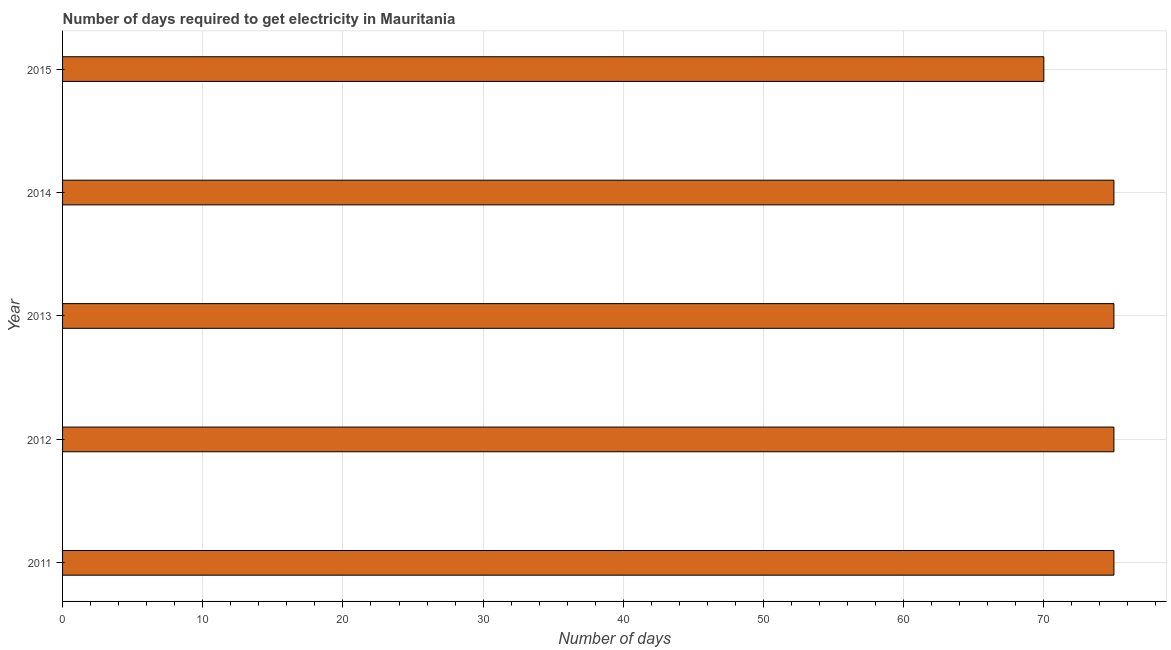What is the title of the graph?
Provide a short and direct response. Number of days required to get electricity in Mauritania. What is the label or title of the X-axis?
Your answer should be very brief. Number of days. What is the label or title of the Y-axis?
Make the answer very short. Year. In which year was the time to get electricity maximum?
Offer a terse response. 2011. In which year was the time to get electricity minimum?
Keep it short and to the point. 2015. What is the sum of the time to get electricity?
Give a very brief answer. 370. What is the difference between the time to get electricity in 2011 and 2013?
Your answer should be compact. 0. What is the median time to get electricity?
Keep it short and to the point. 75. In how many years, is the time to get electricity greater than 12 ?
Offer a terse response. 5. What is the ratio of the time to get electricity in 2012 to that in 2015?
Ensure brevity in your answer.  1.07. Is the difference between the time to get electricity in 2011 and 2015 greater than the difference between any two years?
Ensure brevity in your answer.  Yes. What is the difference between the highest and the second highest time to get electricity?
Provide a succinct answer. 0. In how many years, is the time to get electricity greater than the average time to get electricity taken over all years?
Keep it short and to the point. 4. How many years are there in the graph?
Give a very brief answer. 5. What is the Number of days in 2011?
Make the answer very short. 75. What is the Number of days in 2013?
Offer a terse response. 75. What is the difference between the Number of days in 2011 and 2012?
Keep it short and to the point. 0. What is the difference between the Number of days in 2011 and 2013?
Offer a very short reply. 0. What is the difference between the Number of days in 2011 and 2014?
Provide a short and direct response. 0. What is the difference between the Number of days in 2011 and 2015?
Make the answer very short. 5. What is the difference between the Number of days in 2012 and 2013?
Make the answer very short. 0. What is the difference between the Number of days in 2012 and 2014?
Make the answer very short. 0. What is the difference between the Number of days in 2012 and 2015?
Your response must be concise. 5. What is the difference between the Number of days in 2013 and 2015?
Your response must be concise. 5. What is the ratio of the Number of days in 2011 to that in 2013?
Your answer should be compact. 1. What is the ratio of the Number of days in 2011 to that in 2014?
Offer a very short reply. 1. What is the ratio of the Number of days in 2011 to that in 2015?
Offer a terse response. 1.07. What is the ratio of the Number of days in 2012 to that in 2013?
Keep it short and to the point. 1. What is the ratio of the Number of days in 2012 to that in 2014?
Keep it short and to the point. 1. What is the ratio of the Number of days in 2012 to that in 2015?
Ensure brevity in your answer.  1.07. What is the ratio of the Number of days in 2013 to that in 2015?
Your response must be concise. 1.07. What is the ratio of the Number of days in 2014 to that in 2015?
Your response must be concise. 1.07. 